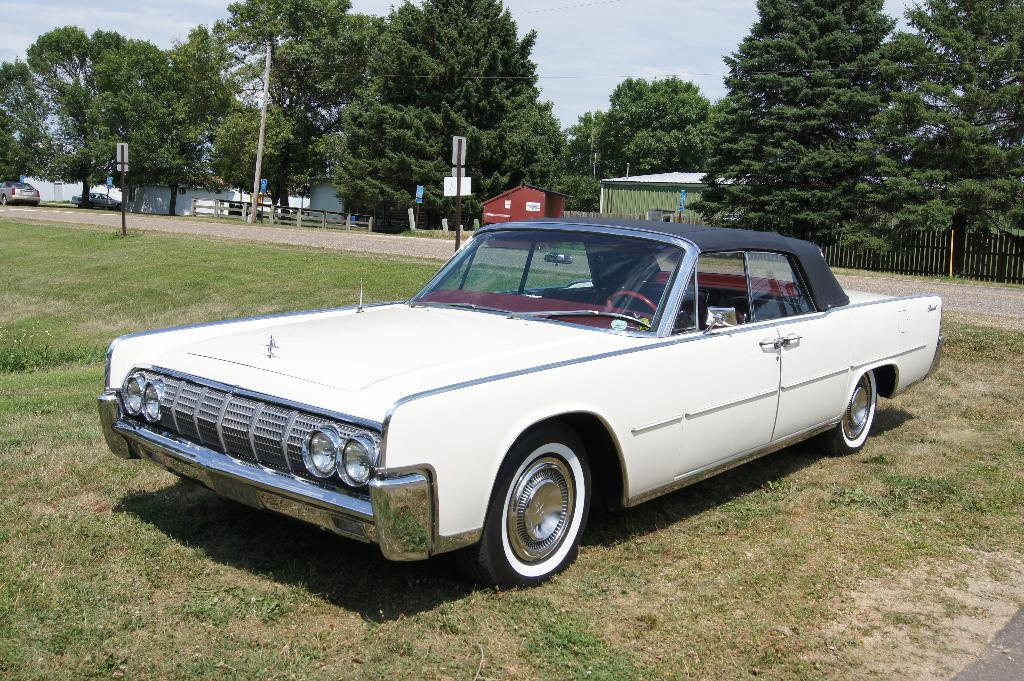What type of car is in the image? There is a white color classic car in the image. Where is the car located? The car is parked on the ground. What can be seen in the background of the image? There are trees and a green shed house visible in the background of the image. What type of cork can be seen in the image? There is no cork present in the image. What team is responsible for maintaining the classic car in the image? The image does not provide information about any team responsible for the car. 